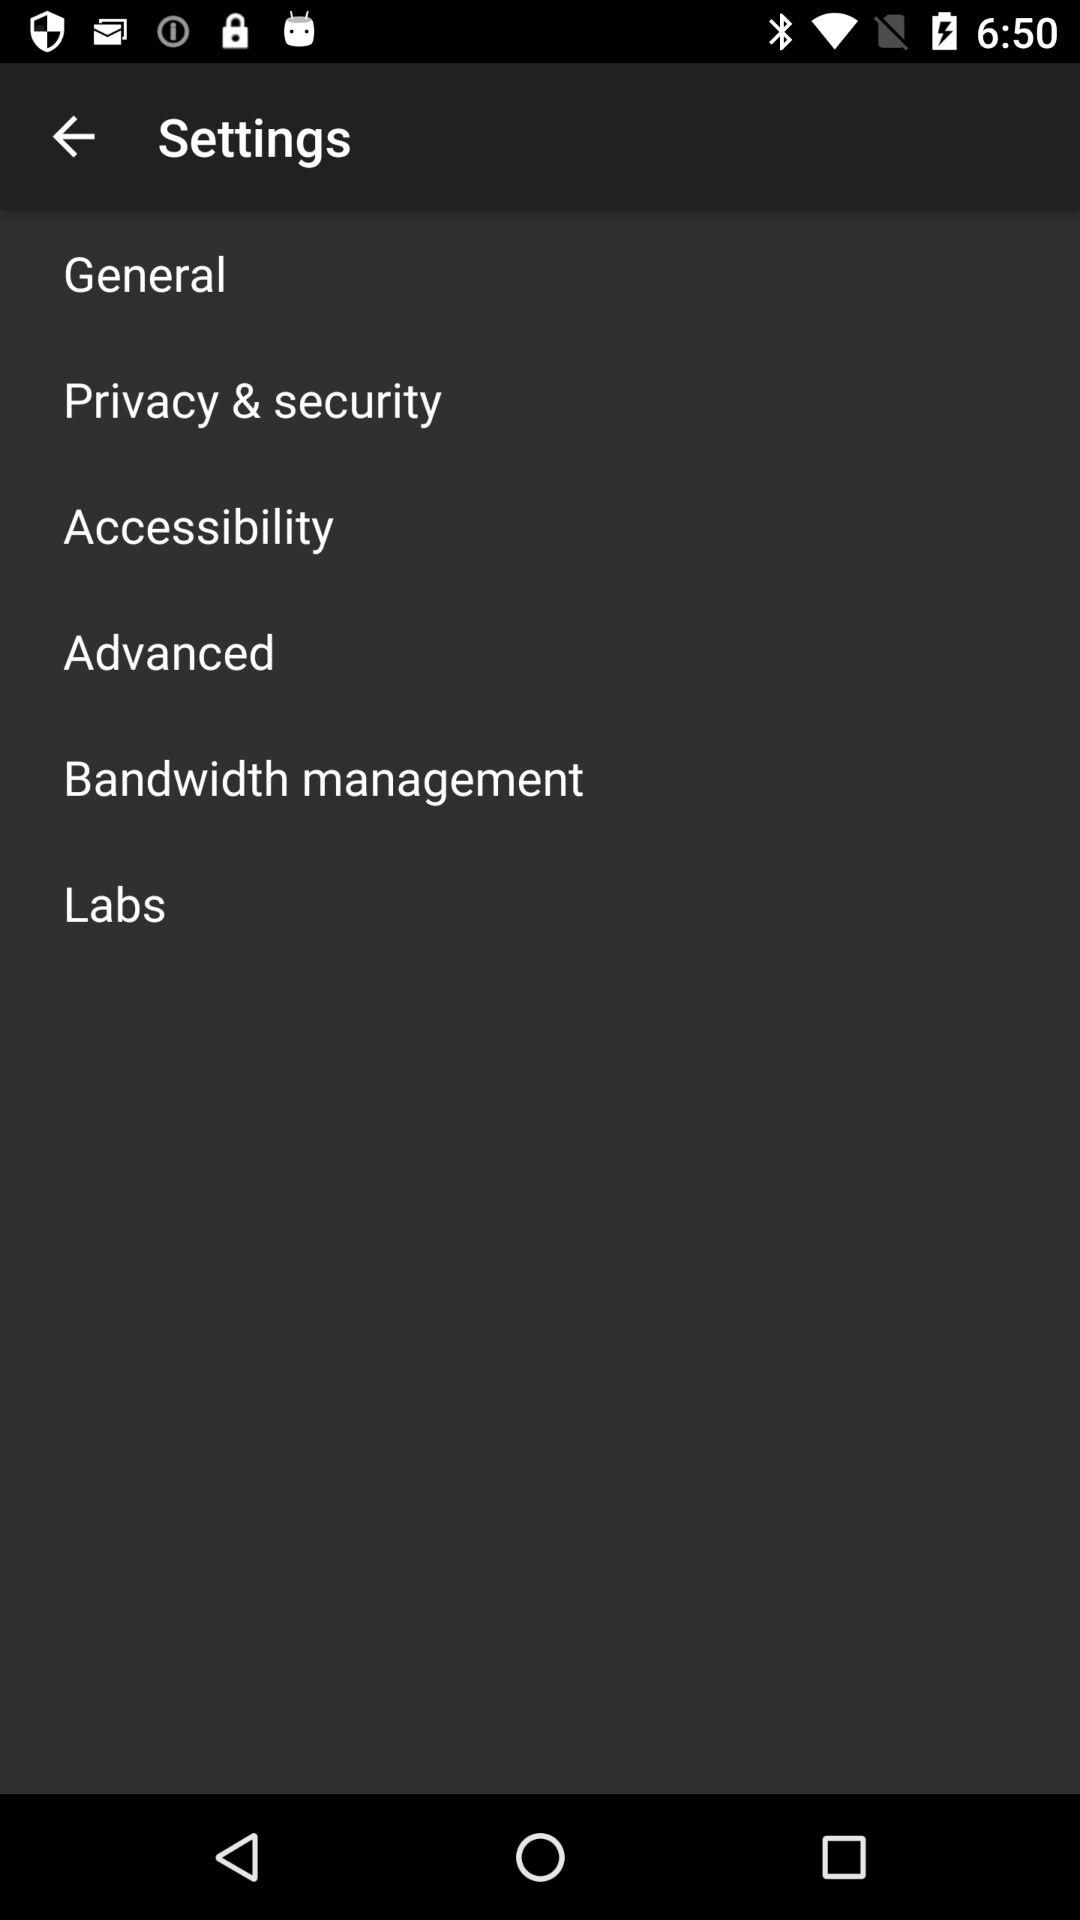How many items are there on the settings menu?
Answer the question using a single word or phrase. 6 